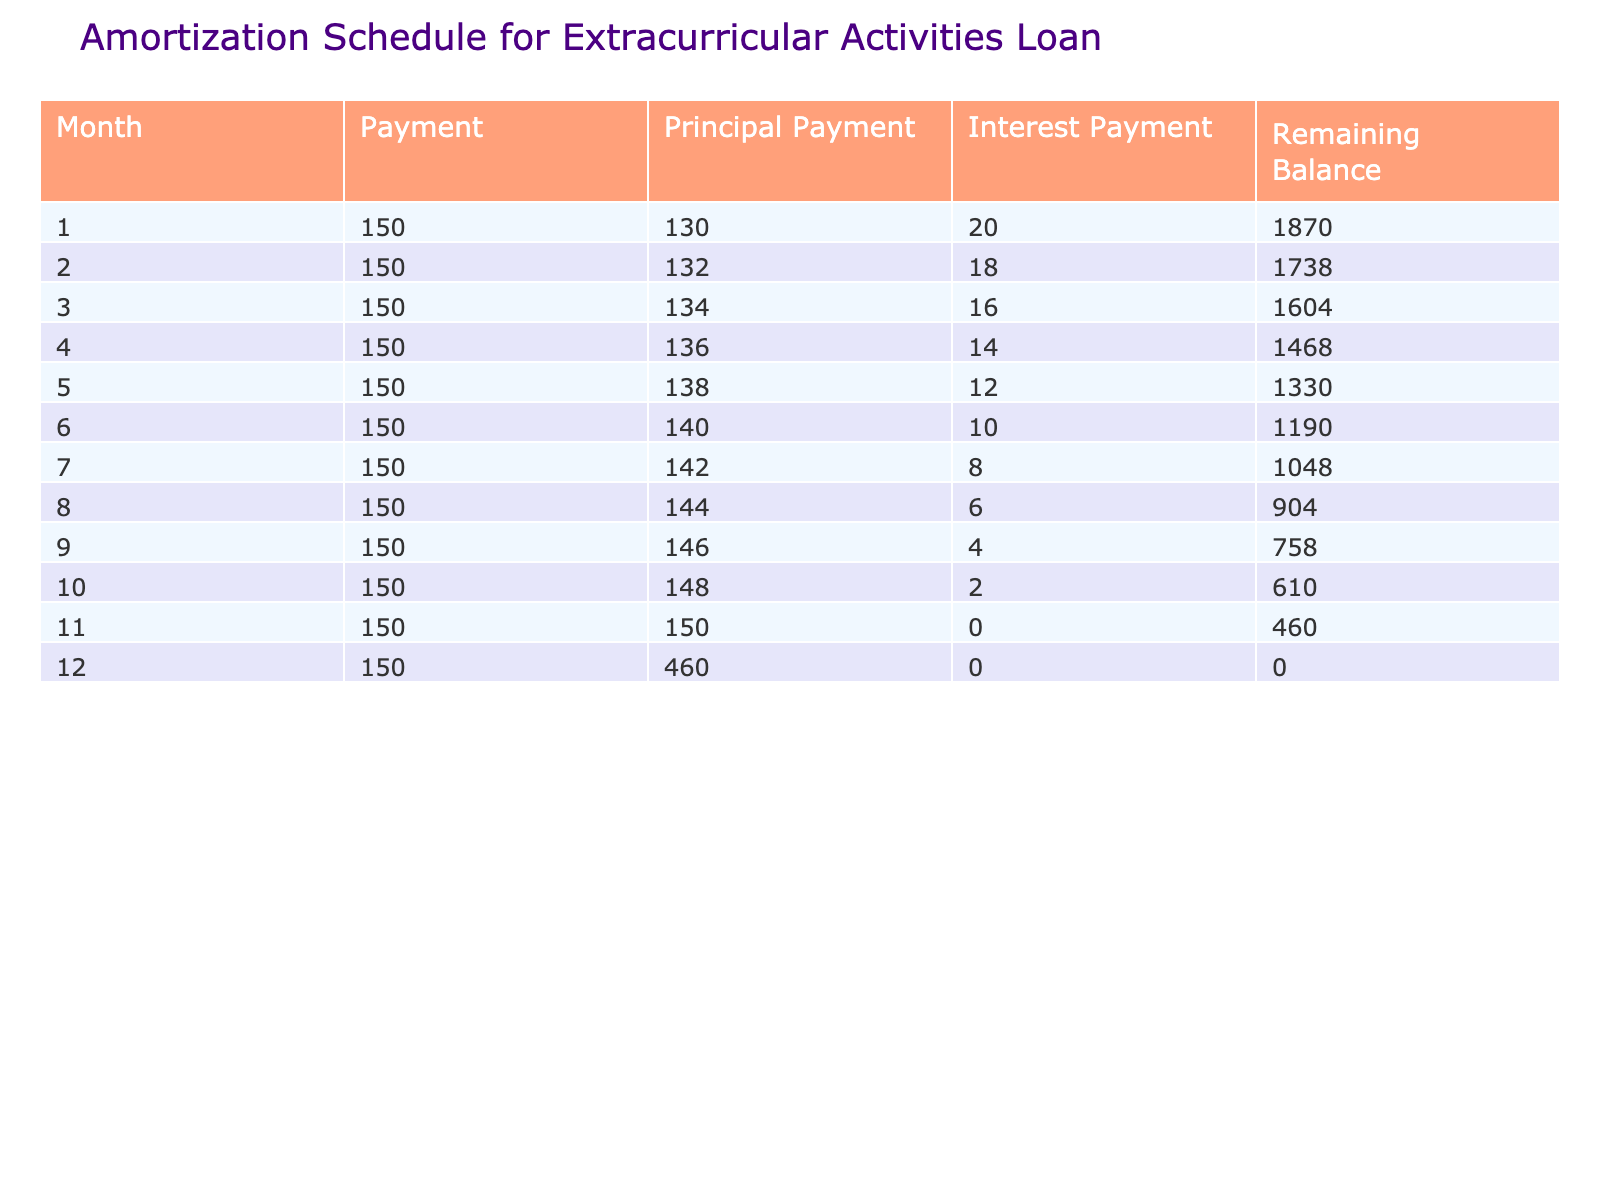What was the interest payment in the first month? The first month shows an interest payment of 20, taken directly from the table under the "Interest Payment" column for Month 1.
Answer: 20 How much did the principal payment increase by from month 1 to month 12? In Month 1, the principal payment is 130. In Month 12, it is 460. The increase is 460 - 130 = 330.
Answer: 330 What is the remaining balance after payment 5? In Month 5, the remaining balance is listed as 1330, so this can be found directly in the "Remaining Balance" column for Month 5.
Answer: 1330 Did the interest payment decrease each month? Yes, the table shows that as we progress from Month 1 to Month 12, interest payments consistently decrease from 20 down to 0, confirming a downward trend.
Answer: Yes What was the total amount paid towards the principal over the entire loan period? To find the total principal payment, add the principal payments from each month: 130 + 132 + 134 + 136 + 138 + 140 + 142 + 144 + 146 + 148 + 150 + 460 = 1672.
Answer: 1672 How much total was paid in interest over the loan period? Sum the interest payments: 20 + 18 + 16 + 14 + 12 + 10 + 8 + 6 + 4 + 2 + 0 + 0 = 0 + 0 + 20 + 18 + 16 + 14 + 12 + 10 + 8 + 6 + 4 + 2 = 132 in total for the entire loan.
Answer: 132 How much was the total payment made in month 11 compared to month 3? The total payment in Month 11 is 150 (same as Month 3). Since both months have the same payment value of 150, the comparison shows that they are equal.
Answer: Both are 150 What is the average monthly payment made over the loan period? The total payment made over 12 months is 150 * 12 = 1800. To find the average, divide that by 12 months, resulting in 1800 / 12 = 150.
Answer: 150 Which month had the highest principal payment? The principal payment peaked at 460 in Month 12, the last month of repayment, according to the "Principal Payment" column.
Answer: Month 12 